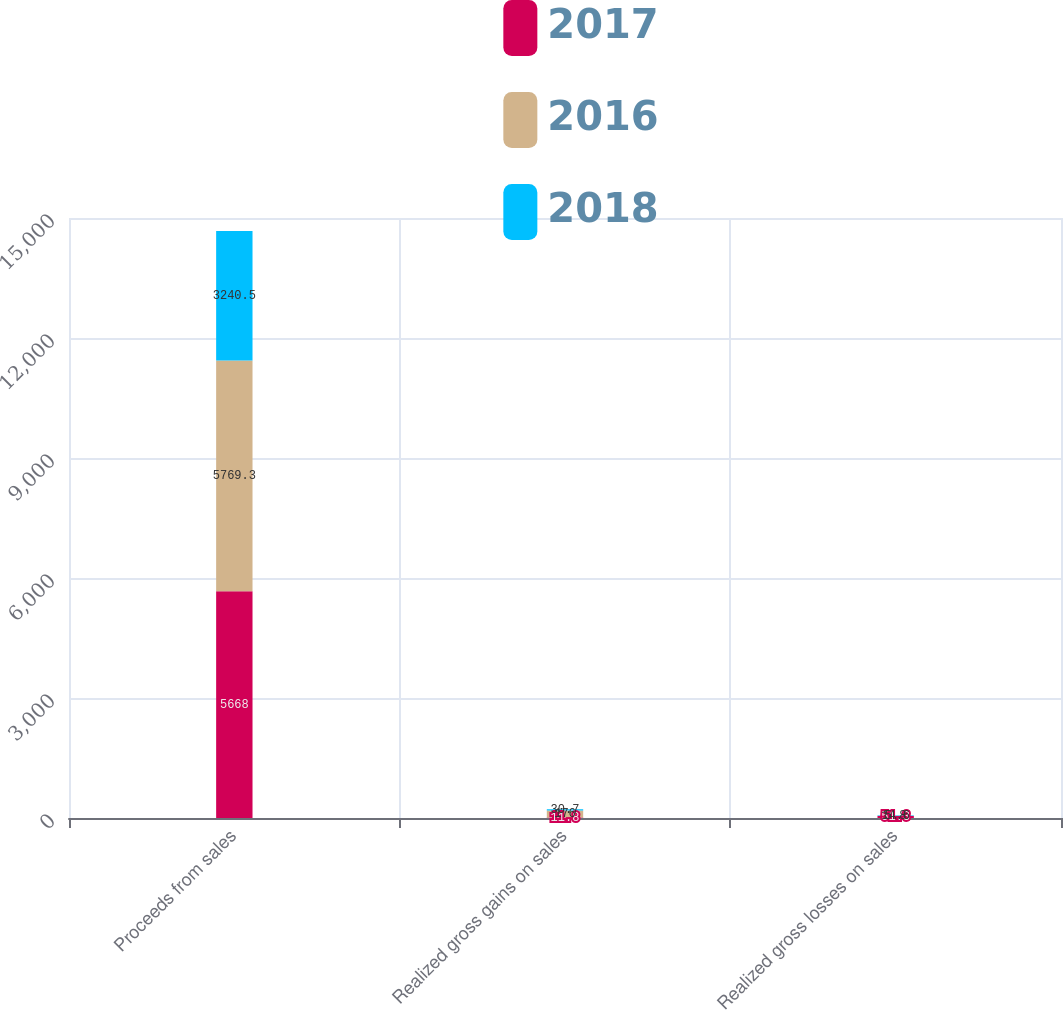Convert chart to OTSL. <chart><loc_0><loc_0><loc_500><loc_500><stacked_bar_chart><ecel><fcel>Proceeds from sales<fcel>Realized gross gains on sales<fcel>Realized gross losses on sales<nl><fcel>2017<fcel>5668<fcel>11.8<fcel>51.3<nl><fcel>2016<fcel>5769.3<fcel>176<fcel>5.8<nl><fcel>2018<fcel>3240.5<fcel>30.7<fcel>14.6<nl></chart> 